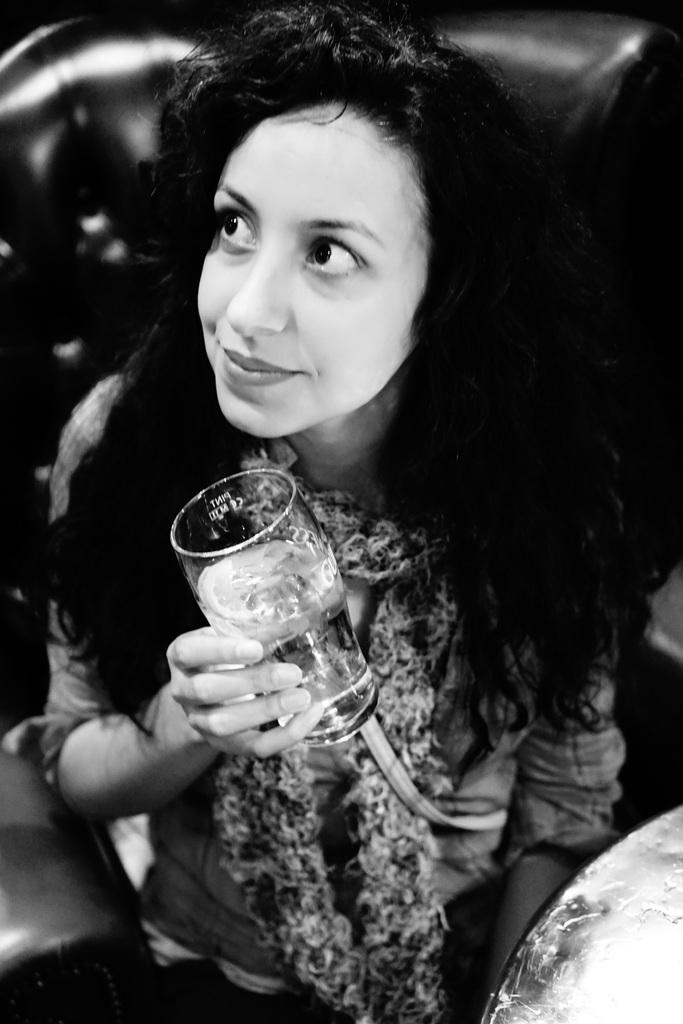Who is present in the image? There is a woman in the image. What is the woman doing in the image? The woman is sitting on a chair. What object is the woman holding in the image? The woman is holding a glass. What type of flag is visible in the image? There is no flag present in the image. What type of laborer is shown working in the image? There is no laborer present in the image; it only features a woman sitting on a chair and holding a glass. 